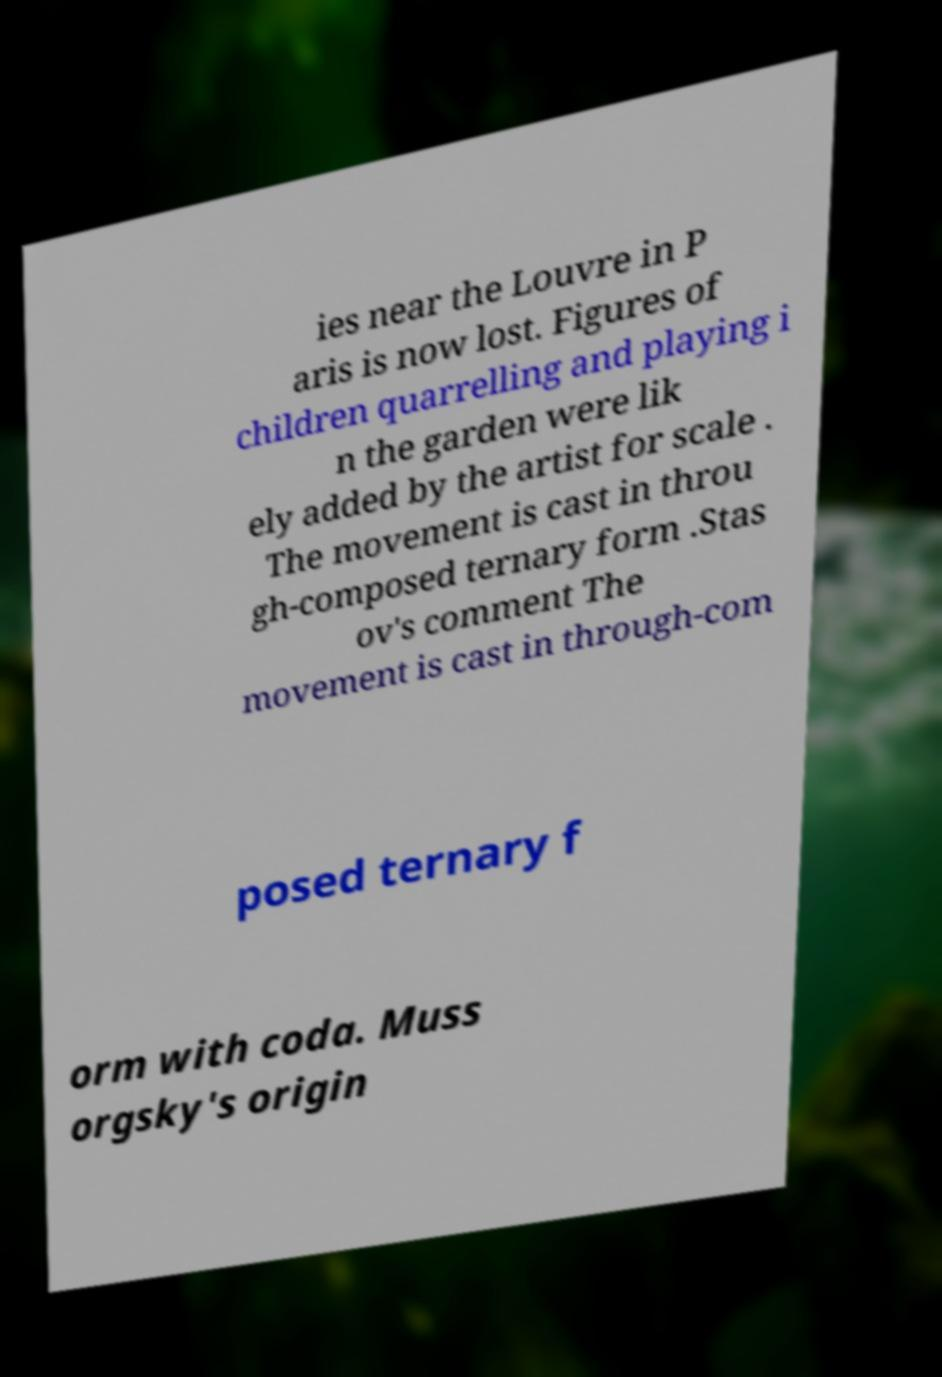There's text embedded in this image that I need extracted. Can you transcribe it verbatim? ies near the Louvre in P aris is now lost. Figures of children quarrelling and playing i n the garden were lik ely added by the artist for scale . The movement is cast in throu gh-composed ternary form .Stas ov's comment The movement is cast in through-com posed ternary f orm with coda. Muss orgsky's origin 